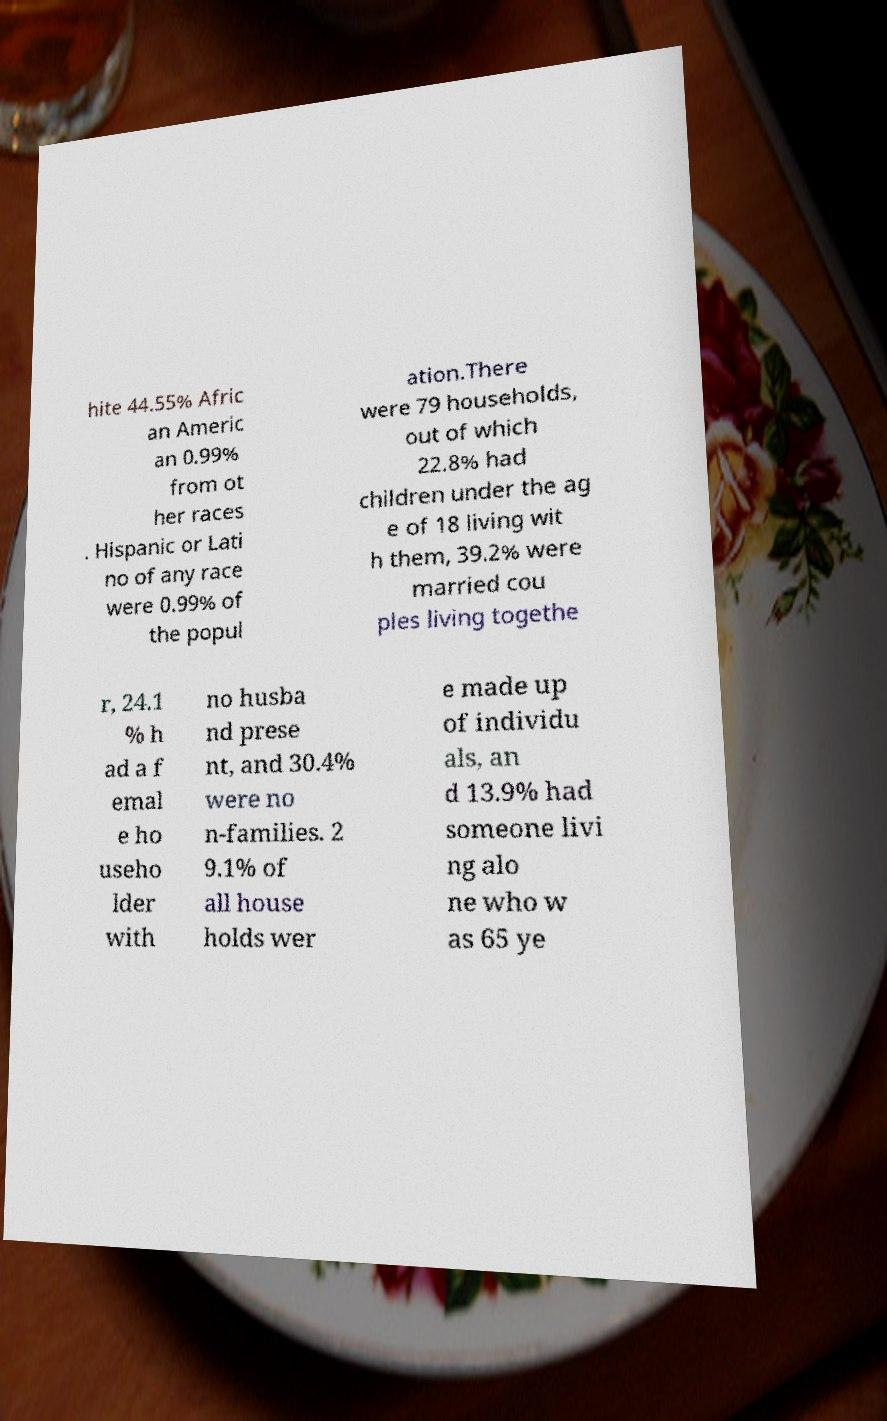Can you read and provide the text displayed in the image?This photo seems to have some interesting text. Can you extract and type it out for me? hite 44.55% Afric an Americ an 0.99% from ot her races . Hispanic or Lati no of any race were 0.99% of the popul ation.There were 79 households, out of which 22.8% had children under the ag e of 18 living wit h them, 39.2% were married cou ples living togethe r, 24.1 % h ad a f emal e ho useho lder with no husba nd prese nt, and 30.4% were no n-families. 2 9.1% of all house holds wer e made up of individu als, an d 13.9% had someone livi ng alo ne who w as 65 ye 